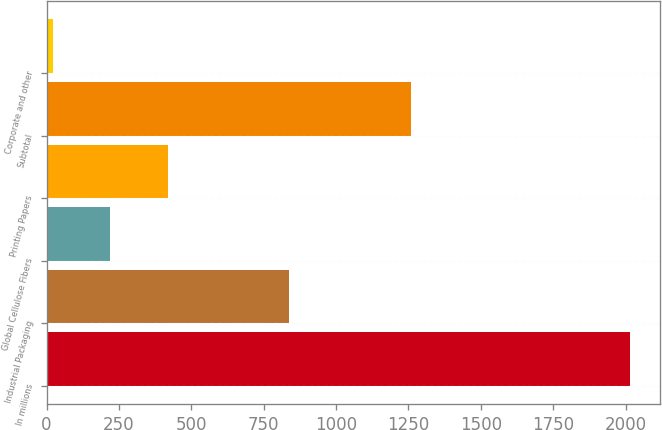<chart> <loc_0><loc_0><loc_500><loc_500><bar_chart><fcel>In millions<fcel>Industrial Packaging<fcel>Global Cellulose Fibers<fcel>Printing Papers<fcel>Subtotal<fcel>Corporate and other<nl><fcel>2017<fcel>836<fcel>220.6<fcel>420.2<fcel>1259<fcel>21<nl></chart> 